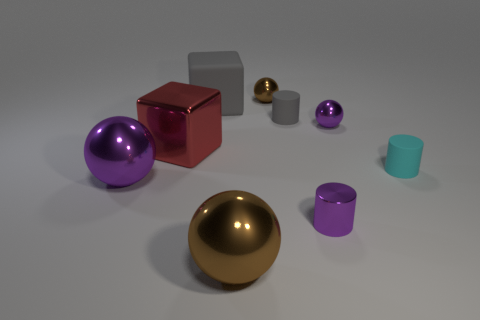Subtract all matte cylinders. How many cylinders are left? 1 Add 1 large purple metal objects. How many objects exist? 10 Subtract all purple cylinders. How many cylinders are left? 2 Subtract 1 blocks. How many blocks are left? 1 Subtract all spheres. How many objects are left? 5 Add 8 cyan things. How many cyan things are left? 9 Add 4 big rubber spheres. How many big rubber spheres exist? 4 Subtract 2 purple balls. How many objects are left? 7 Subtract all blue cylinders. Subtract all cyan spheres. How many cylinders are left? 3 Subtract all yellow spheres. How many brown cubes are left? 0 